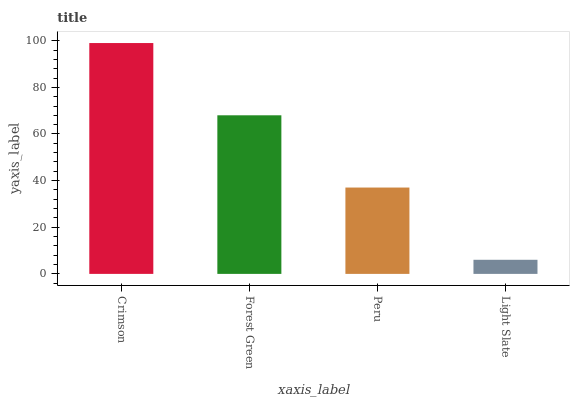Is Light Slate the minimum?
Answer yes or no. Yes. Is Crimson the maximum?
Answer yes or no. Yes. Is Forest Green the minimum?
Answer yes or no. No. Is Forest Green the maximum?
Answer yes or no. No. Is Crimson greater than Forest Green?
Answer yes or no. Yes. Is Forest Green less than Crimson?
Answer yes or no. Yes. Is Forest Green greater than Crimson?
Answer yes or no. No. Is Crimson less than Forest Green?
Answer yes or no. No. Is Forest Green the high median?
Answer yes or no. Yes. Is Peru the low median?
Answer yes or no. Yes. Is Peru the high median?
Answer yes or no. No. Is Forest Green the low median?
Answer yes or no. No. 